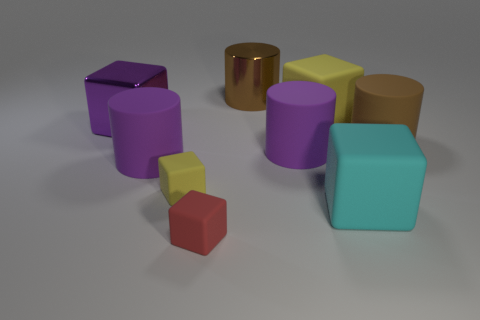Subtract 2 blocks. How many blocks are left? 3 Subtract all tiny yellow matte blocks. How many blocks are left? 4 Subtract all yellow blocks. How many blocks are left? 3 Add 1 large metal blocks. How many objects exist? 10 Subtract all green cylinders. Subtract all purple balls. How many cylinders are left? 4 Subtract all blocks. How many objects are left? 4 Subtract 0 gray blocks. How many objects are left? 9 Subtract all brown rubber objects. Subtract all yellow blocks. How many objects are left? 6 Add 7 small objects. How many small objects are left? 9 Add 6 big cubes. How many big cubes exist? 9 